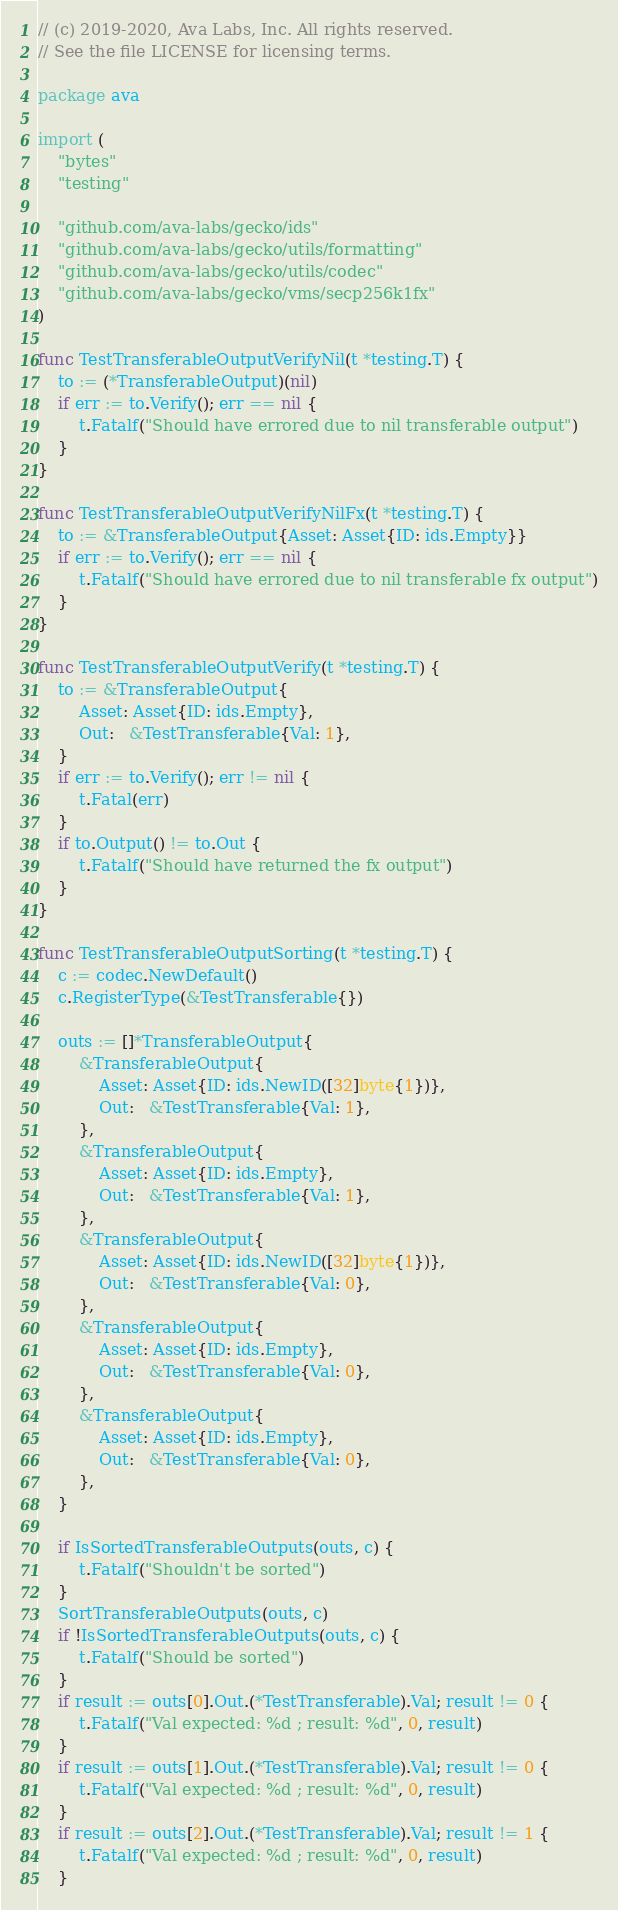<code> <loc_0><loc_0><loc_500><loc_500><_Go_>// (c) 2019-2020, Ava Labs, Inc. All rights reserved.
// See the file LICENSE for licensing terms.

package ava

import (
	"bytes"
	"testing"

	"github.com/ava-labs/gecko/ids"
	"github.com/ava-labs/gecko/utils/formatting"
	"github.com/ava-labs/gecko/utils/codec"
	"github.com/ava-labs/gecko/vms/secp256k1fx"
)

func TestTransferableOutputVerifyNil(t *testing.T) {
	to := (*TransferableOutput)(nil)
	if err := to.Verify(); err == nil {
		t.Fatalf("Should have errored due to nil transferable output")
	}
}

func TestTransferableOutputVerifyNilFx(t *testing.T) {
	to := &TransferableOutput{Asset: Asset{ID: ids.Empty}}
	if err := to.Verify(); err == nil {
		t.Fatalf("Should have errored due to nil transferable fx output")
	}
}

func TestTransferableOutputVerify(t *testing.T) {
	to := &TransferableOutput{
		Asset: Asset{ID: ids.Empty},
		Out:   &TestTransferable{Val: 1},
	}
	if err := to.Verify(); err != nil {
		t.Fatal(err)
	}
	if to.Output() != to.Out {
		t.Fatalf("Should have returned the fx output")
	}
}

func TestTransferableOutputSorting(t *testing.T) {
	c := codec.NewDefault()
	c.RegisterType(&TestTransferable{})

	outs := []*TransferableOutput{
		&TransferableOutput{
			Asset: Asset{ID: ids.NewID([32]byte{1})},
			Out:   &TestTransferable{Val: 1},
		},
		&TransferableOutput{
			Asset: Asset{ID: ids.Empty},
			Out:   &TestTransferable{Val: 1},
		},
		&TransferableOutput{
			Asset: Asset{ID: ids.NewID([32]byte{1})},
			Out:   &TestTransferable{Val: 0},
		},
		&TransferableOutput{
			Asset: Asset{ID: ids.Empty},
			Out:   &TestTransferable{Val: 0},
		},
		&TransferableOutput{
			Asset: Asset{ID: ids.Empty},
			Out:   &TestTransferable{Val: 0},
		},
	}

	if IsSortedTransferableOutputs(outs, c) {
		t.Fatalf("Shouldn't be sorted")
	}
	SortTransferableOutputs(outs, c)
	if !IsSortedTransferableOutputs(outs, c) {
		t.Fatalf("Should be sorted")
	}
	if result := outs[0].Out.(*TestTransferable).Val; result != 0 {
		t.Fatalf("Val expected: %d ; result: %d", 0, result)
	}
	if result := outs[1].Out.(*TestTransferable).Val; result != 0 {
		t.Fatalf("Val expected: %d ; result: %d", 0, result)
	}
	if result := outs[2].Out.(*TestTransferable).Val; result != 1 {
		t.Fatalf("Val expected: %d ; result: %d", 0, result)
	}</code> 